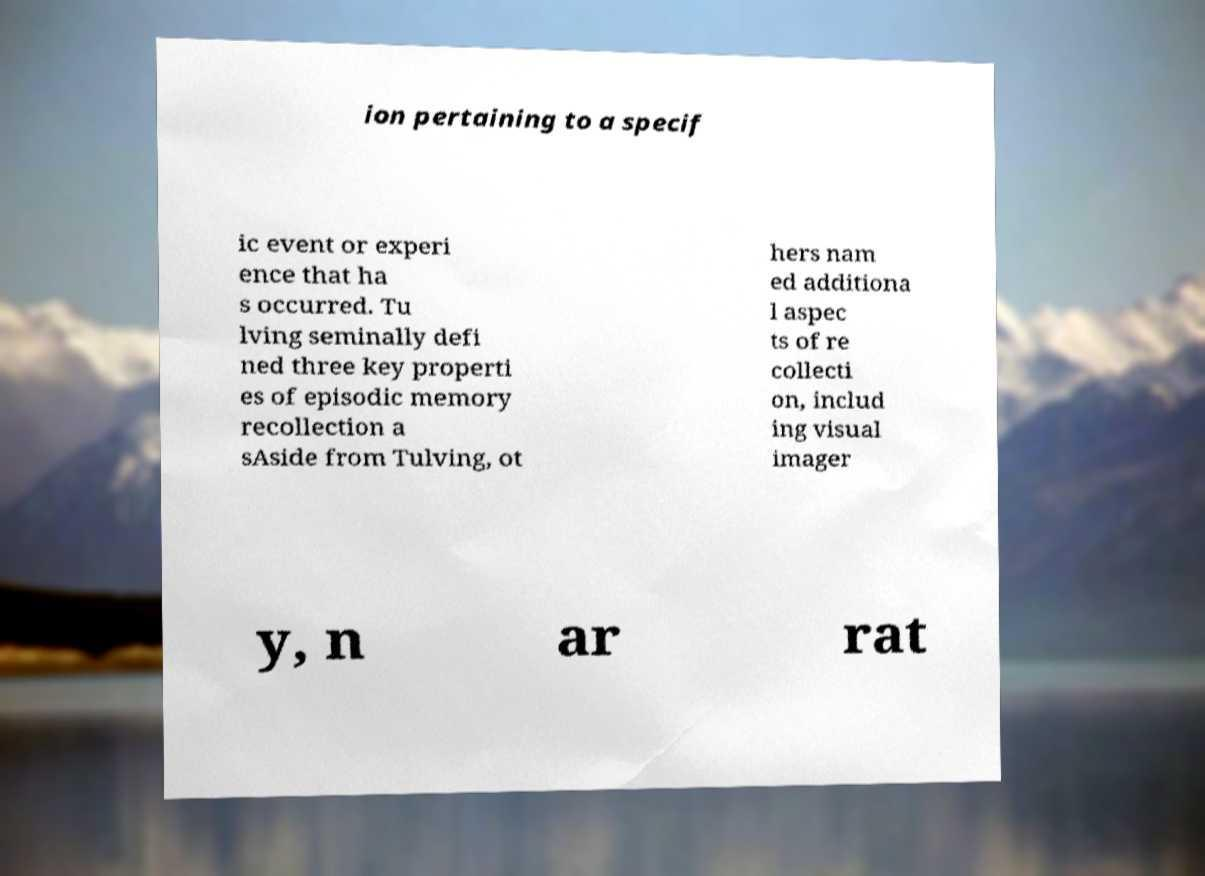I need the written content from this picture converted into text. Can you do that? ion pertaining to a specif ic event or experi ence that ha s occurred. Tu lving seminally defi ned three key properti es of episodic memory recollection a sAside from Tulving, ot hers nam ed additiona l aspec ts of re collecti on, includ ing visual imager y, n ar rat 